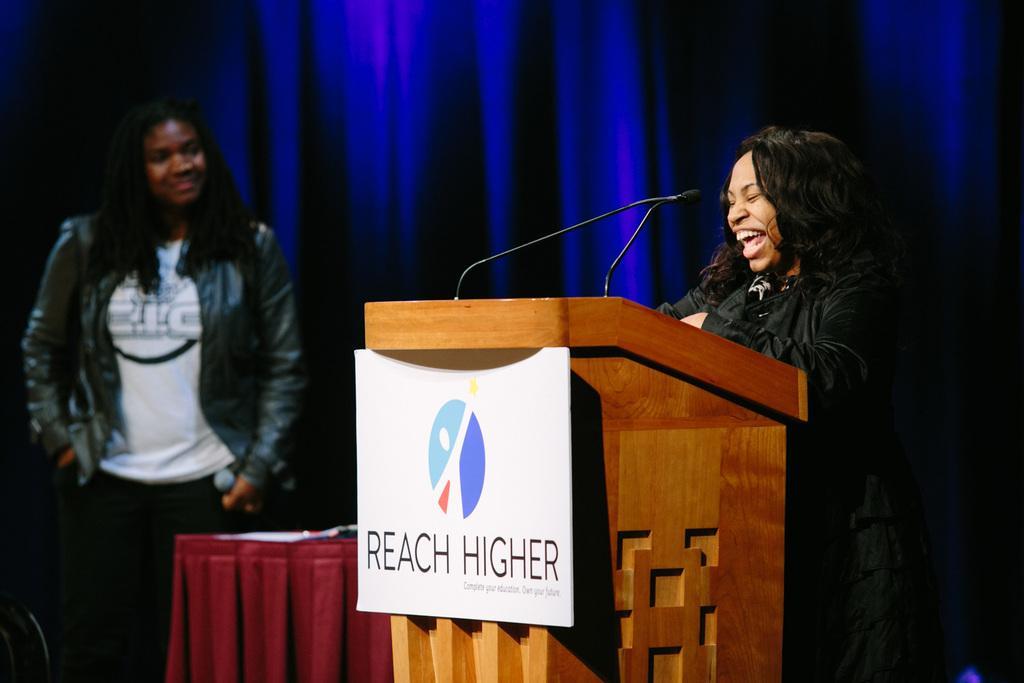In one or two sentences, can you explain what this image depicts? On the right side of the image we can see a lady standing, before her there is a podium and we can see mics placed on the podium. At the bottom there is a table. On the left there is a lady standing and holding a mic. In the background there is a curtain. 